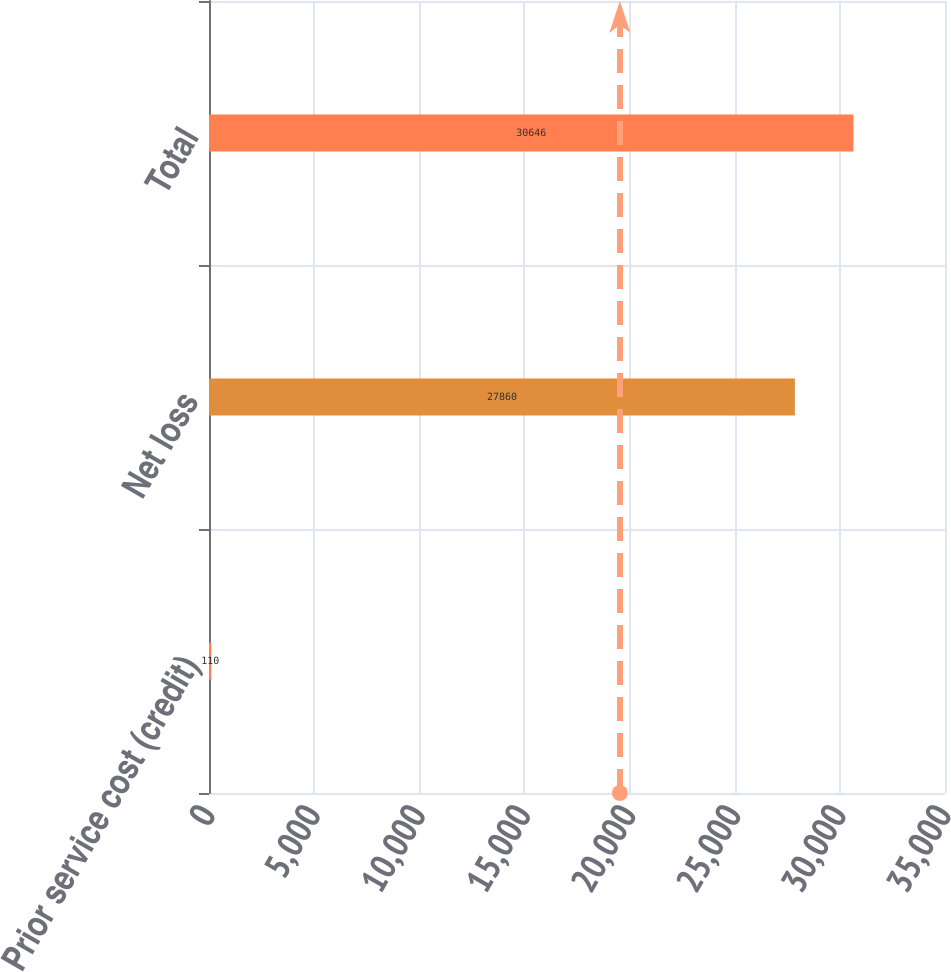Convert chart. <chart><loc_0><loc_0><loc_500><loc_500><bar_chart><fcel>Prior service cost (credit)<fcel>Net loss<fcel>Total<nl><fcel>110<fcel>27860<fcel>30646<nl></chart> 